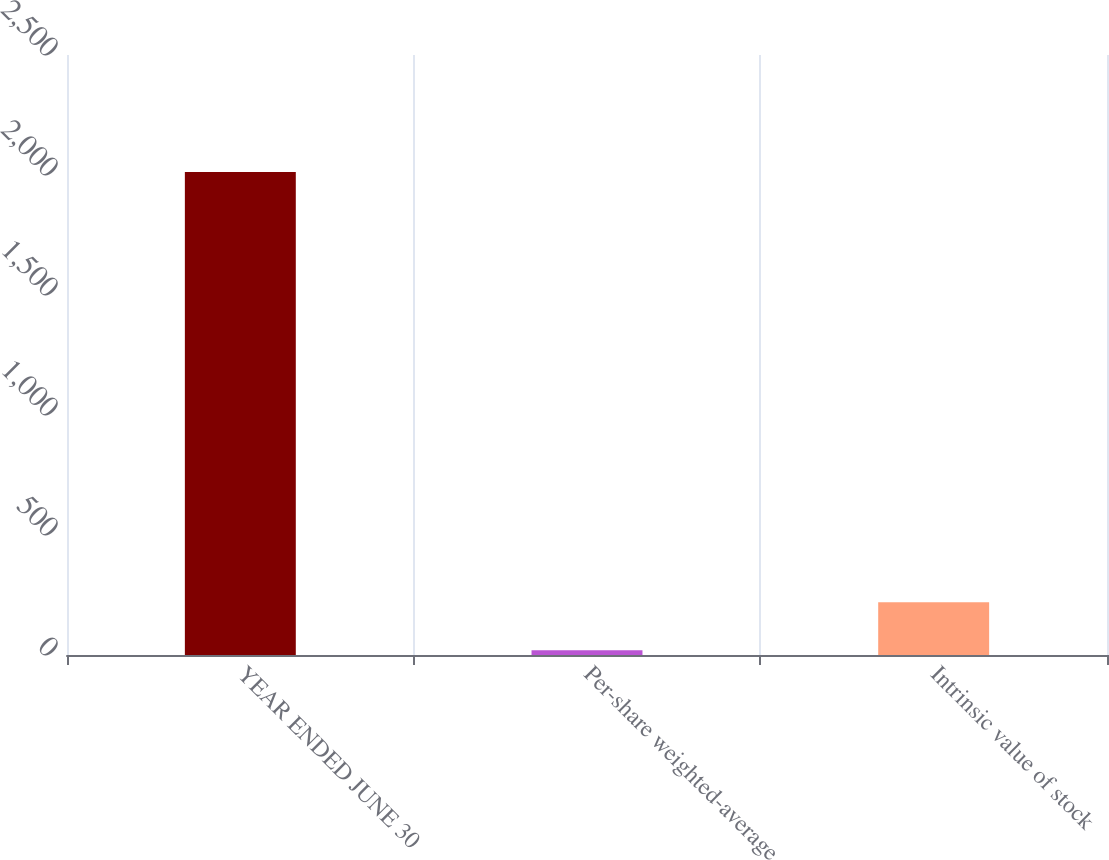Convert chart to OTSL. <chart><loc_0><loc_0><loc_500><loc_500><bar_chart><fcel>YEAR ENDED JUNE 30<fcel>Per-share weighted-average<fcel>Intrinsic value of stock<nl><fcel>2013<fcel>20.3<fcel>219.57<nl></chart> 